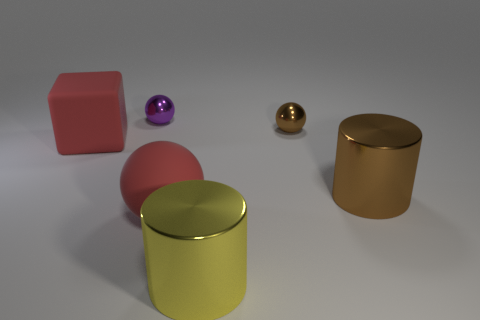Subtract all tiny purple shiny spheres. How many spheres are left? 2 Add 1 small brown metallic balls. How many objects exist? 7 Subtract all brown cylinders. How many cylinders are left? 1 Subtract all cylinders. How many objects are left? 4 Add 4 big metallic cubes. How many big metallic cubes exist? 4 Subtract 0 yellow cubes. How many objects are left? 6 Subtract 1 cubes. How many cubes are left? 0 Subtract all brown cylinders. Subtract all brown blocks. How many cylinders are left? 1 Subtract all yellow cylinders. How many green blocks are left? 0 Subtract all small cylinders. Subtract all brown balls. How many objects are left? 5 